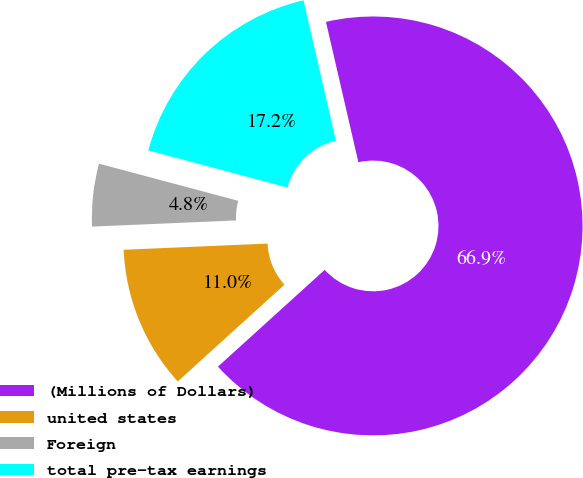Convert chart to OTSL. <chart><loc_0><loc_0><loc_500><loc_500><pie_chart><fcel>(Millions of Dollars)<fcel>united states<fcel>Foreign<fcel>total pre-tax earnings<nl><fcel>66.89%<fcel>11.04%<fcel>4.83%<fcel>17.24%<nl></chart> 